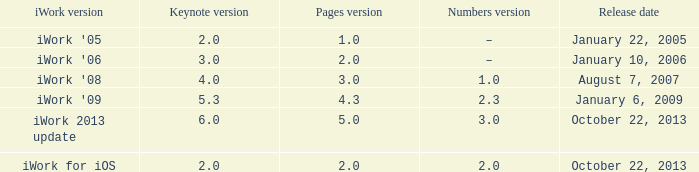Help me parse the entirety of this table. {'header': ['iWork version', 'Keynote version', 'Pages version', 'Numbers version', 'Release date'], 'rows': [["iWork '05", '2.0', '1.0', '–', 'January 22, 2005'], ["iWork '06", '3.0', '2.0', '–', 'January 10, 2006'], ["iWork '08", '4.0', '3.0', '1.0', 'August 7, 2007'], ["iWork '09", '5.3', '4.3', '2.3', 'January 6, 2009'], ['iWork 2013 update', '6.0', '5.0', '3.0', 'October 22, 2013'], ['iWork for iOS', '2.0', '2.0', '2.0', 'October 22, 2013']]} What version of iWork was released on October 22, 2013 with a pages version greater than 2? Iwork 2013 update. 